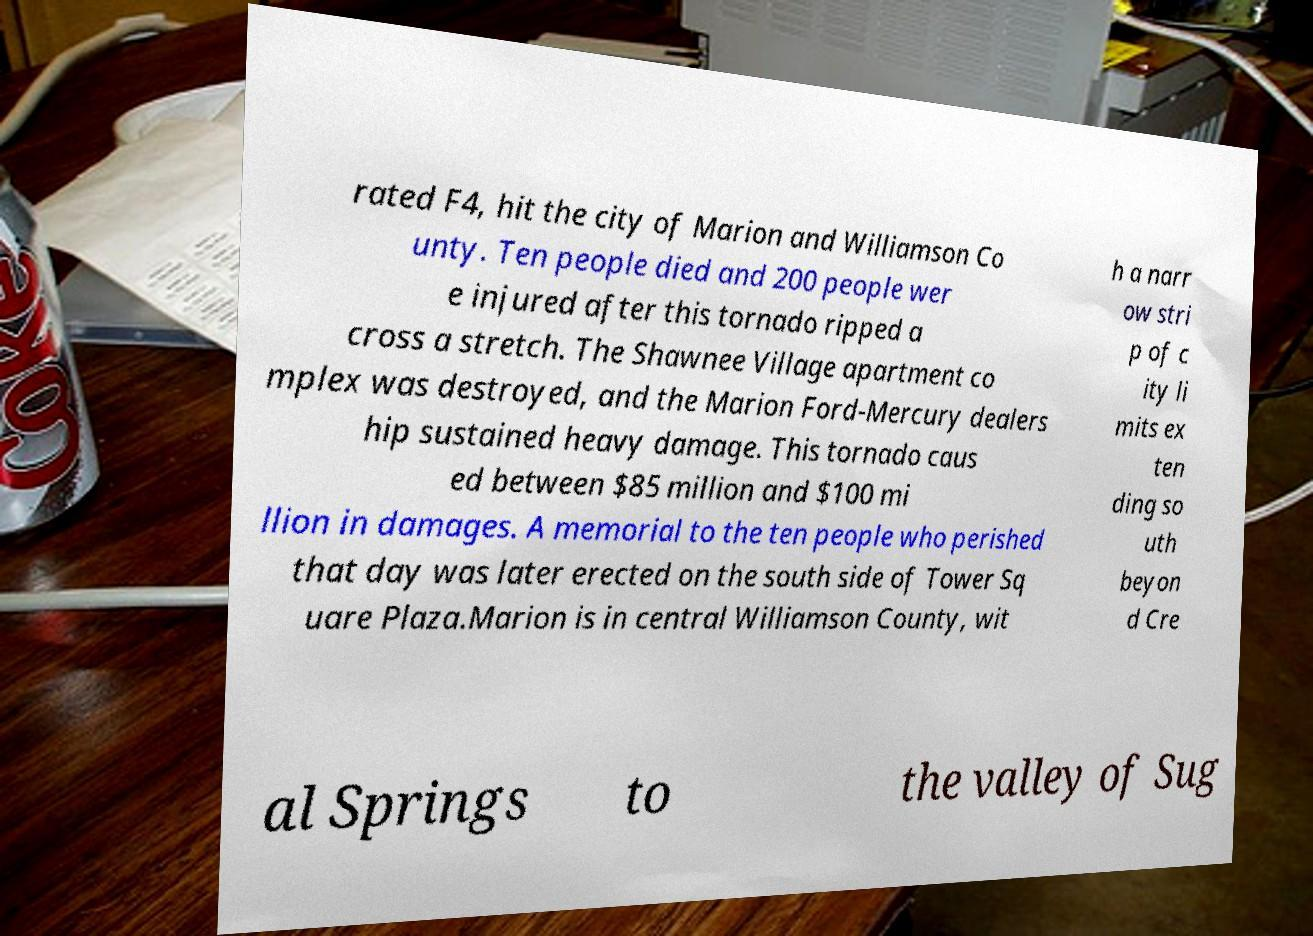Could you extract and type out the text from this image? rated F4, hit the city of Marion and Williamson Co unty. Ten people died and 200 people wer e injured after this tornado ripped a cross a stretch. The Shawnee Village apartment co mplex was destroyed, and the Marion Ford-Mercury dealers hip sustained heavy damage. This tornado caus ed between $85 million and $100 mi llion in damages. A memorial to the ten people who perished that day was later erected on the south side of Tower Sq uare Plaza.Marion is in central Williamson County, wit h a narr ow stri p of c ity li mits ex ten ding so uth beyon d Cre al Springs to the valley of Sug 